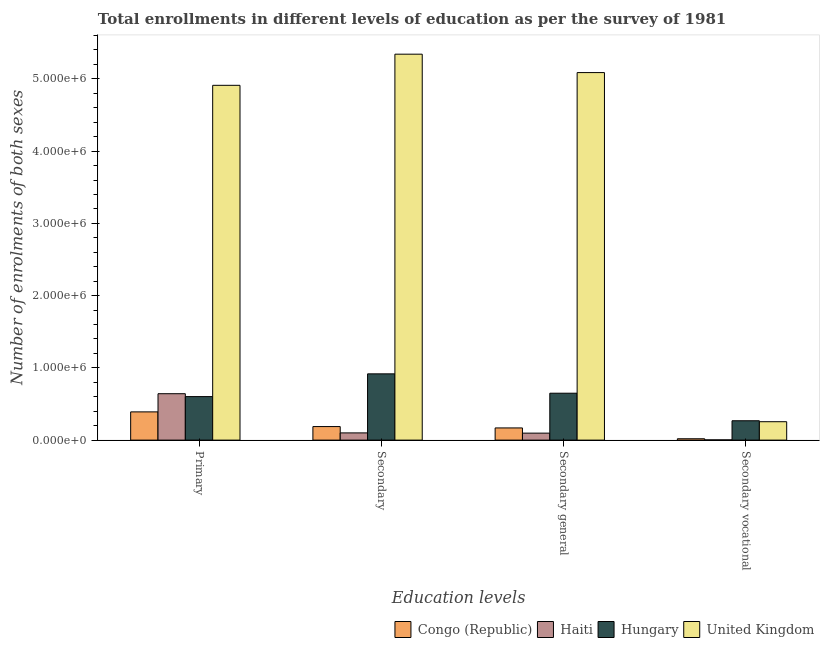Are the number of bars on each tick of the X-axis equal?
Your answer should be very brief. Yes. How many bars are there on the 4th tick from the left?
Offer a terse response. 4. What is the label of the 4th group of bars from the left?
Offer a very short reply. Secondary vocational. What is the number of enrolments in primary education in United Kingdom?
Provide a succinct answer. 4.91e+06. Across all countries, what is the maximum number of enrolments in secondary education?
Your response must be concise. 5.34e+06. Across all countries, what is the minimum number of enrolments in secondary general education?
Offer a terse response. 9.66e+04. In which country was the number of enrolments in secondary vocational education maximum?
Your answer should be compact. Hungary. In which country was the number of enrolments in secondary general education minimum?
Make the answer very short. Haiti. What is the total number of enrolments in primary education in the graph?
Make the answer very short. 6.55e+06. What is the difference between the number of enrolments in primary education in Hungary and that in Congo (Republic)?
Keep it short and to the point. 2.12e+05. What is the difference between the number of enrolments in secondary vocational education in United Kingdom and the number of enrolments in secondary education in Congo (Republic)?
Make the answer very short. 6.72e+04. What is the average number of enrolments in secondary vocational education per country?
Give a very brief answer. 1.36e+05. What is the difference between the number of enrolments in secondary education and number of enrolments in secondary vocational education in United Kingdom?
Your answer should be very brief. 5.09e+06. What is the ratio of the number of enrolments in primary education in Hungary to that in United Kingdom?
Provide a succinct answer. 0.12. Is the number of enrolments in secondary general education in Congo (Republic) less than that in United Kingdom?
Make the answer very short. Yes. Is the difference between the number of enrolments in secondary general education in United Kingdom and Congo (Republic) greater than the difference between the number of enrolments in secondary vocational education in United Kingdom and Congo (Republic)?
Keep it short and to the point. Yes. What is the difference between the highest and the second highest number of enrolments in secondary education?
Make the answer very short. 4.42e+06. What is the difference between the highest and the lowest number of enrolments in secondary education?
Your answer should be compact. 5.24e+06. Is it the case that in every country, the sum of the number of enrolments in secondary education and number of enrolments in secondary general education is greater than the sum of number of enrolments in secondary vocational education and number of enrolments in primary education?
Offer a terse response. No. What does the 1st bar from the left in Primary represents?
Make the answer very short. Congo (Republic). How many bars are there?
Make the answer very short. 16. What is the difference between two consecutive major ticks on the Y-axis?
Your response must be concise. 1.00e+06. Are the values on the major ticks of Y-axis written in scientific E-notation?
Keep it short and to the point. Yes. What is the title of the graph?
Offer a terse response. Total enrollments in different levels of education as per the survey of 1981. What is the label or title of the X-axis?
Provide a short and direct response. Education levels. What is the label or title of the Y-axis?
Your response must be concise. Number of enrolments of both sexes. What is the Number of enrolments of both sexes in Congo (Republic) in Primary?
Ensure brevity in your answer.  3.91e+05. What is the Number of enrolments of both sexes in Haiti in Primary?
Your response must be concise. 6.42e+05. What is the Number of enrolments of both sexes of Hungary in Primary?
Ensure brevity in your answer.  6.02e+05. What is the Number of enrolments of both sexes of United Kingdom in Primary?
Your answer should be very brief. 4.91e+06. What is the Number of enrolments of both sexes of Congo (Republic) in Secondary?
Provide a short and direct response. 1.88e+05. What is the Number of enrolments of both sexes in Haiti in Secondary?
Offer a very short reply. 9.99e+04. What is the Number of enrolments of both sexes in Hungary in Secondary?
Give a very brief answer. 9.17e+05. What is the Number of enrolments of both sexes of United Kingdom in Secondary?
Provide a succinct answer. 5.34e+06. What is the Number of enrolments of both sexes in Congo (Republic) in Secondary general?
Your answer should be compact. 1.69e+05. What is the Number of enrolments of both sexes of Haiti in Secondary general?
Your answer should be compact. 9.66e+04. What is the Number of enrolments of both sexes in Hungary in Secondary general?
Ensure brevity in your answer.  6.49e+05. What is the Number of enrolments of both sexes in United Kingdom in Secondary general?
Ensure brevity in your answer.  5.09e+06. What is the Number of enrolments of both sexes in Congo (Republic) in Secondary vocational?
Your answer should be compact. 1.89e+04. What is the Number of enrolments of both sexes of Haiti in Secondary vocational?
Your response must be concise. 3298. What is the Number of enrolments of both sexes of Hungary in Secondary vocational?
Offer a terse response. 2.68e+05. What is the Number of enrolments of both sexes in United Kingdom in Secondary vocational?
Your answer should be very brief. 2.55e+05. Across all Education levels, what is the maximum Number of enrolments of both sexes of Congo (Republic)?
Provide a succinct answer. 3.91e+05. Across all Education levels, what is the maximum Number of enrolments of both sexes in Haiti?
Provide a succinct answer. 6.42e+05. Across all Education levels, what is the maximum Number of enrolments of both sexes of Hungary?
Provide a succinct answer. 9.17e+05. Across all Education levels, what is the maximum Number of enrolments of both sexes of United Kingdom?
Offer a very short reply. 5.34e+06. Across all Education levels, what is the minimum Number of enrolments of both sexes of Congo (Republic)?
Keep it short and to the point. 1.89e+04. Across all Education levels, what is the minimum Number of enrolments of both sexes in Haiti?
Give a very brief answer. 3298. Across all Education levels, what is the minimum Number of enrolments of both sexes of Hungary?
Your response must be concise. 2.68e+05. Across all Education levels, what is the minimum Number of enrolments of both sexes in United Kingdom?
Your answer should be compact. 2.55e+05. What is the total Number of enrolments of both sexes of Congo (Republic) in the graph?
Offer a terse response. 7.66e+05. What is the total Number of enrolments of both sexes in Haiti in the graph?
Your answer should be compact. 8.42e+05. What is the total Number of enrolments of both sexes of Hungary in the graph?
Provide a short and direct response. 2.44e+06. What is the total Number of enrolments of both sexes in United Kingdom in the graph?
Keep it short and to the point. 1.56e+07. What is the difference between the Number of enrolments of both sexes of Congo (Republic) in Primary and that in Secondary?
Offer a very short reply. 2.03e+05. What is the difference between the Number of enrolments of both sexes in Haiti in Primary and that in Secondary?
Provide a short and direct response. 5.42e+05. What is the difference between the Number of enrolments of both sexes in Hungary in Primary and that in Secondary?
Provide a short and direct response. -3.15e+05. What is the difference between the Number of enrolments of both sexes of United Kingdom in Primary and that in Secondary?
Offer a terse response. -4.31e+05. What is the difference between the Number of enrolments of both sexes of Congo (Republic) in Primary and that in Secondary general?
Make the answer very short. 2.22e+05. What is the difference between the Number of enrolments of both sexes in Haiti in Primary and that in Secondary general?
Offer a very short reply. 5.46e+05. What is the difference between the Number of enrolments of both sexes in Hungary in Primary and that in Secondary general?
Your answer should be very brief. -4.70e+04. What is the difference between the Number of enrolments of both sexes in United Kingdom in Primary and that in Secondary general?
Give a very brief answer. -1.76e+05. What is the difference between the Number of enrolments of both sexes in Congo (Republic) in Primary and that in Secondary vocational?
Your answer should be compact. 3.72e+05. What is the difference between the Number of enrolments of both sexes of Haiti in Primary and that in Secondary vocational?
Offer a terse response. 6.39e+05. What is the difference between the Number of enrolments of both sexes of Hungary in Primary and that in Secondary vocational?
Your response must be concise. 3.34e+05. What is the difference between the Number of enrolments of both sexes of United Kingdom in Primary and that in Secondary vocational?
Ensure brevity in your answer.  4.66e+06. What is the difference between the Number of enrolments of both sexes of Congo (Republic) in Secondary and that in Secondary general?
Make the answer very short. 1.89e+04. What is the difference between the Number of enrolments of both sexes in Haiti in Secondary and that in Secondary general?
Make the answer very short. 3298. What is the difference between the Number of enrolments of both sexes of Hungary in Secondary and that in Secondary general?
Keep it short and to the point. 2.68e+05. What is the difference between the Number of enrolments of both sexes in United Kingdom in Secondary and that in Secondary general?
Give a very brief answer. 2.55e+05. What is the difference between the Number of enrolments of both sexes in Congo (Republic) in Secondary and that in Secondary vocational?
Provide a succinct answer. 1.69e+05. What is the difference between the Number of enrolments of both sexes in Haiti in Secondary and that in Secondary vocational?
Offer a very short reply. 9.66e+04. What is the difference between the Number of enrolments of both sexes of Hungary in Secondary and that in Secondary vocational?
Ensure brevity in your answer.  6.49e+05. What is the difference between the Number of enrolments of both sexes of United Kingdom in Secondary and that in Secondary vocational?
Provide a succinct answer. 5.09e+06. What is the difference between the Number of enrolments of both sexes in Congo (Republic) in Secondary general and that in Secondary vocational?
Your answer should be very brief. 1.50e+05. What is the difference between the Number of enrolments of both sexes in Haiti in Secondary general and that in Secondary vocational?
Offer a terse response. 9.33e+04. What is the difference between the Number of enrolments of both sexes of Hungary in Secondary general and that in Secondary vocational?
Keep it short and to the point. 3.81e+05. What is the difference between the Number of enrolments of both sexes in United Kingdom in Secondary general and that in Secondary vocational?
Offer a terse response. 4.83e+06. What is the difference between the Number of enrolments of both sexes in Congo (Republic) in Primary and the Number of enrolments of both sexes in Haiti in Secondary?
Keep it short and to the point. 2.91e+05. What is the difference between the Number of enrolments of both sexes in Congo (Republic) in Primary and the Number of enrolments of both sexes in Hungary in Secondary?
Give a very brief answer. -5.27e+05. What is the difference between the Number of enrolments of both sexes of Congo (Republic) in Primary and the Number of enrolments of both sexes of United Kingdom in Secondary?
Give a very brief answer. -4.95e+06. What is the difference between the Number of enrolments of both sexes of Haiti in Primary and the Number of enrolments of both sexes of Hungary in Secondary?
Provide a succinct answer. -2.75e+05. What is the difference between the Number of enrolments of both sexes in Haiti in Primary and the Number of enrolments of both sexes in United Kingdom in Secondary?
Provide a succinct answer. -4.70e+06. What is the difference between the Number of enrolments of both sexes of Hungary in Primary and the Number of enrolments of both sexes of United Kingdom in Secondary?
Your answer should be compact. -4.74e+06. What is the difference between the Number of enrolments of both sexes of Congo (Republic) in Primary and the Number of enrolments of both sexes of Haiti in Secondary general?
Provide a succinct answer. 2.94e+05. What is the difference between the Number of enrolments of both sexes of Congo (Republic) in Primary and the Number of enrolments of both sexes of Hungary in Secondary general?
Offer a terse response. -2.59e+05. What is the difference between the Number of enrolments of both sexes of Congo (Republic) in Primary and the Number of enrolments of both sexes of United Kingdom in Secondary general?
Keep it short and to the point. -4.70e+06. What is the difference between the Number of enrolments of both sexes in Haiti in Primary and the Number of enrolments of both sexes in Hungary in Secondary general?
Your response must be concise. -6894. What is the difference between the Number of enrolments of both sexes of Haiti in Primary and the Number of enrolments of both sexes of United Kingdom in Secondary general?
Your response must be concise. -4.44e+06. What is the difference between the Number of enrolments of both sexes in Hungary in Primary and the Number of enrolments of both sexes in United Kingdom in Secondary general?
Your answer should be very brief. -4.48e+06. What is the difference between the Number of enrolments of both sexes in Congo (Republic) in Primary and the Number of enrolments of both sexes in Haiti in Secondary vocational?
Ensure brevity in your answer.  3.87e+05. What is the difference between the Number of enrolments of both sexes in Congo (Republic) in Primary and the Number of enrolments of both sexes in Hungary in Secondary vocational?
Provide a succinct answer. 1.23e+05. What is the difference between the Number of enrolments of both sexes of Congo (Republic) in Primary and the Number of enrolments of both sexes of United Kingdom in Secondary vocational?
Offer a very short reply. 1.36e+05. What is the difference between the Number of enrolments of both sexes in Haiti in Primary and the Number of enrolments of both sexes in Hungary in Secondary vocational?
Offer a terse response. 3.74e+05. What is the difference between the Number of enrolments of both sexes of Haiti in Primary and the Number of enrolments of both sexes of United Kingdom in Secondary vocational?
Offer a terse response. 3.88e+05. What is the difference between the Number of enrolments of both sexes of Hungary in Primary and the Number of enrolments of both sexes of United Kingdom in Secondary vocational?
Give a very brief answer. 3.48e+05. What is the difference between the Number of enrolments of both sexes in Congo (Republic) in Secondary and the Number of enrolments of both sexes in Haiti in Secondary general?
Provide a short and direct response. 9.10e+04. What is the difference between the Number of enrolments of both sexes of Congo (Republic) in Secondary and the Number of enrolments of both sexes of Hungary in Secondary general?
Offer a terse response. -4.62e+05. What is the difference between the Number of enrolments of both sexes of Congo (Republic) in Secondary and the Number of enrolments of both sexes of United Kingdom in Secondary general?
Your answer should be compact. -4.90e+06. What is the difference between the Number of enrolments of both sexes in Haiti in Secondary and the Number of enrolments of both sexes in Hungary in Secondary general?
Give a very brief answer. -5.49e+05. What is the difference between the Number of enrolments of both sexes in Haiti in Secondary and the Number of enrolments of both sexes in United Kingdom in Secondary general?
Keep it short and to the point. -4.99e+06. What is the difference between the Number of enrolments of both sexes in Hungary in Secondary and the Number of enrolments of both sexes in United Kingdom in Secondary general?
Keep it short and to the point. -4.17e+06. What is the difference between the Number of enrolments of both sexes of Congo (Republic) in Secondary and the Number of enrolments of both sexes of Haiti in Secondary vocational?
Your answer should be very brief. 1.84e+05. What is the difference between the Number of enrolments of both sexes in Congo (Republic) in Secondary and the Number of enrolments of both sexes in Hungary in Secondary vocational?
Offer a terse response. -8.03e+04. What is the difference between the Number of enrolments of both sexes in Congo (Republic) in Secondary and the Number of enrolments of both sexes in United Kingdom in Secondary vocational?
Make the answer very short. -6.72e+04. What is the difference between the Number of enrolments of both sexes in Haiti in Secondary and the Number of enrolments of both sexes in Hungary in Secondary vocational?
Your answer should be very brief. -1.68e+05. What is the difference between the Number of enrolments of both sexes in Haiti in Secondary and the Number of enrolments of both sexes in United Kingdom in Secondary vocational?
Offer a very short reply. -1.55e+05. What is the difference between the Number of enrolments of both sexes of Hungary in Secondary and the Number of enrolments of both sexes of United Kingdom in Secondary vocational?
Your answer should be very brief. 6.62e+05. What is the difference between the Number of enrolments of both sexes of Congo (Republic) in Secondary general and the Number of enrolments of both sexes of Haiti in Secondary vocational?
Provide a short and direct response. 1.65e+05. What is the difference between the Number of enrolments of both sexes in Congo (Republic) in Secondary general and the Number of enrolments of both sexes in Hungary in Secondary vocational?
Your response must be concise. -9.92e+04. What is the difference between the Number of enrolments of both sexes of Congo (Republic) in Secondary general and the Number of enrolments of both sexes of United Kingdom in Secondary vocational?
Your answer should be compact. -8.61e+04. What is the difference between the Number of enrolments of both sexes in Haiti in Secondary general and the Number of enrolments of both sexes in Hungary in Secondary vocational?
Your answer should be very brief. -1.71e+05. What is the difference between the Number of enrolments of both sexes of Haiti in Secondary general and the Number of enrolments of both sexes of United Kingdom in Secondary vocational?
Your response must be concise. -1.58e+05. What is the difference between the Number of enrolments of both sexes in Hungary in Secondary general and the Number of enrolments of both sexes in United Kingdom in Secondary vocational?
Give a very brief answer. 3.94e+05. What is the average Number of enrolments of both sexes of Congo (Republic) per Education levels?
Make the answer very short. 1.91e+05. What is the average Number of enrolments of both sexes of Haiti per Education levels?
Give a very brief answer. 2.11e+05. What is the average Number of enrolments of both sexes in Hungary per Education levels?
Provide a succinct answer. 6.09e+05. What is the average Number of enrolments of both sexes in United Kingdom per Education levels?
Make the answer very short. 3.90e+06. What is the difference between the Number of enrolments of both sexes in Congo (Republic) and Number of enrolments of both sexes in Haiti in Primary?
Ensure brevity in your answer.  -2.52e+05. What is the difference between the Number of enrolments of both sexes in Congo (Republic) and Number of enrolments of both sexes in Hungary in Primary?
Your response must be concise. -2.12e+05. What is the difference between the Number of enrolments of both sexes in Congo (Republic) and Number of enrolments of both sexes in United Kingdom in Primary?
Make the answer very short. -4.52e+06. What is the difference between the Number of enrolments of both sexes in Haiti and Number of enrolments of both sexes in Hungary in Primary?
Make the answer very short. 4.01e+04. What is the difference between the Number of enrolments of both sexes of Haiti and Number of enrolments of both sexes of United Kingdom in Primary?
Offer a terse response. -4.27e+06. What is the difference between the Number of enrolments of both sexes of Hungary and Number of enrolments of both sexes of United Kingdom in Primary?
Offer a terse response. -4.31e+06. What is the difference between the Number of enrolments of both sexes in Congo (Republic) and Number of enrolments of both sexes in Haiti in Secondary?
Provide a short and direct response. 8.77e+04. What is the difference between the Number of enrolments of both sexes in Congo (Republic) and Number of enrolments of both sexes in Hungary in Secondary?
Your response must be concise. -7.30e+05. What is the difference between the Number of enrolments of both sexes in Congo (Republic) and Number of enrolments of both sexes in United Kingdom in Secondary?
Ensure brevity in your answer.  -5.15e+06. What is the difference between the Number of enrolments of both sexes of Haiti and Number of enrolments of both sexes of Hungary in Secondary?
Provide a short and direct response. -8.17e+05. What is the difference between the Number of enrolments of both sexes of Haiti and Number of enrolments of both sexes of United Kingdom in Secondary?
Keep it short and to the point. -5.24e+06. What is the difference between the Number of enrolments of both sexes in Hungary and Number of enrolments of both sexes in United Kingdom in Secondary?
Provide a succinct answer. -4.42e+06. What is the difference between the Number of enrolments of both sexes of Congo (Republic) and Number of enrolments of both sexes of Haiti in Secondary general?
Your answer should be compact. 7.21e+04. What is the difference between the Number of enrolments of both sexes in Congo (Republic) and Number of enrolments of both sexes in Hungary in Secondary general?
Your response must be concise. -4.81e+05. What is the difference between the Number of enrolments of both sexes of Congo (Republic) and Number of enrolments of both sexes of United Kingdom in Secondary general?
Make the answer very short. -4.92e+06. What is the difference between the Number of enrolments of both sexes in Haiti and Number of enrolments of both sexes in Hungary in Secondary general?
Your answer should be compact. -5.53e+05. What is the difference between the Number of enrolments of both sexes of Haiti and Number of enrolments of both sexes of United Kingdom in Secondary general?
Your response must be concise. -4.99e+06. What is the difference between the Number of enrolments of both sexes in Hungary and Number of enrolments of both sexes in United Kingdom in Secondary general?
Your response must be concise. -4.44e+06. What is the difference between the Number of enrolments of both sexes in Congo (Republic) and Number of enrolments of both sexes in Haiti in Secondary vocational?
Provide a succinct answer. 1.56e+04. What is the difference between the Number of enrolments of both sexes of Congo (Republic) and Number of enrolments of both sexes of Hungary in Secondary vocational?
Offer a terse response. -2.49e+05. What is the difference between the Number of enrolments of both sexes of Congo (Republic) and Number of enrolments of both sexes of United Kingdom in Secondary vocational?
Ensure brevity in your answer.  -2.36e+05. What is the difference between the Number of enrolments of both sexes of Haiti and Number of enrolments of both sexes of Hungary in Secondary vocational?
Keep it short and to the point. -2.65e+05. What is the difference between the Number of enrolments of both sexes in Haiti and Number of enrolments of both sexes in United Kingdom in Secondary vocational?
Give a very brief answer. -2.52e+05. What is the difference between the Number of enrolments of both sexes of Hungary and Number of enrolments of both sexes of United Kingdom in Secondary vocational?
Make the answer very short. 1.31e+04. What is the ratio of the Number of enrolments of both sexes of Congo (Republic) in Primary to that in Secondary?
Ensure brevity in your answer.  2.08. What is the ratio of the Number of enrolments of both sexes of Haiti in Primary to that in Secondary?
Provide a succinct answer. 6.43. What is the ratio of the Number of enrolments of both sexes in Hungary in Primary to that in Secondary?
Your response must be concise. 0.66. What is the ratio of the Number of enrolments of both sexes of United Kingdom in Primary to that in Secondary?
Make the answer very short. 0.92. What is the ratio of the Number of enrolments of both sexes of Congo (Republic) in Primary to that in Secondary general?
Offer a terse response. 2.32. What is the ratio of the Number of enrolments of both sexes of Haiti in Primary to that in Secondary general?
Your response must be concise. 6.65. What is the ratio of the Number of enrolments of both sexes of Hungary in Primary to that in Secondary general?
Provide a succinct answer. 0.93. What is the ratio of the Number of enrolments of both sexes in United Kingdom in Primary to that in Secondary general?
Ensure brevity in your answer.  0.97. What is the ratio of the Number of enrolments of both sexes in Congo (Republic) in Primary to that in Secondary vocational?
Provide a succinct answer. 20.71. What is the ratio of the Number of enrolments of both sexes in Haiti in Primary to that in Secondary vocational?
Make the answer very short. 194.78. What is the ratio of the Number of enrolments of both sexes in Hungary in Primary to that in Secondary vocational?
Offer a terse response. 2.25. What is the ratio of the Number of enrolments of both sexes of United Kingdom in Primary to that in Secondary vocational?
Ensure brevity in your answer.  19.27. What is the ratio of the Number of enrolments of both sexes of Congo (Republic) in Secondary to that in Secondary general?
Your answer should be compact. 1.11. What is the ratio of the Number of enrolments of both sexes in Haiti in Secondary to that in Secondary general?
Offer a terse response. 1.03. What is the ratio of the Number of enrolments of both sexes of Hungary in Secondary to that in Secondary general?
Your response must be concise. 1.41. What is the ratio of the Number of enrolments of both sexes of United Kingdom in Secondary to that in Secondary general?
Keep it short and to the point. 1.05. What is the ratio of the Number of enrolments of both sexes in Congo (Republic) in Secondary to that in Secondary vocational?
Ensure brevity in your answer.  9.94. What is the ratio of the Number of enrolments of both sexes in Haiti in Secondary to that in Secondary vocational?
Your answer should be compact. 30.29. What is the ratio of the Number of enrolments of both sexes of Hungary in Secondary to that in Secondary vocational?
Make the answer very short. 3.42. What is the ratio of the Number of enrolments of both sexes in United Kingdom in Secondary to that in Secondary vocational?
Your response must be concise. 20.96. What is the ratio of the Number of enrolments of both sexes in Congo (Republic) in Secondary general to that in Secondary vocational?
Provide a short and direct response. 8.94. What is the ratio of the Number of enrolments of both sexes in Haiti in Secondary general to that in Secondary vocational?
Your answer should be very brief. 29.29. What is the ratio of the Number of enrolments of both sexes in Hungary in Secondary general to that in Secondary vocational?
Provide a succinct answer. 2.42. What is the ratio of the Number of enrolments of both sexes in United Kingdom in Secondary general to that in Secondary vocational?
Your response must be concise. 19.96. What is the difference between the highest and the second highest Number of enrolments of both sexes of Congo (Republic)?
Give a very brief answer. 2.03e+05. What is the difference between the highest and the second highest Number of enrolments of both sexes of Haiti?
Provide a short and direct response. 5.42e+05. What is the difference between the highest and the second highest Number of enrolments of both sexes in Hungary?
Your answer should be compact. 2.68e+05. What is the difference between the highest and the second highest Number of enrolments of both sexes of United Kingdom?
Offer a terse response. 2.55e+05. What is the difference between the highest and the lowest Number of enrolments of both sexes in Congo (Republic)?
Your response must be concise. 3.72e+05. What is the difference between the highest and the lowest Number of enrolments of both sexes of Haiti?
Your response must be concise. 6.39e+05. What is the difference between the highest and the lowest Number of enrolments of both sexes of Hungary?
Keep it short and to the point. 6.49e+05. What is the difference between the highest and the lowest Number of enrolments of both sexes in United Kingdom?
Your answer should be very brief. 5.09e+06. 